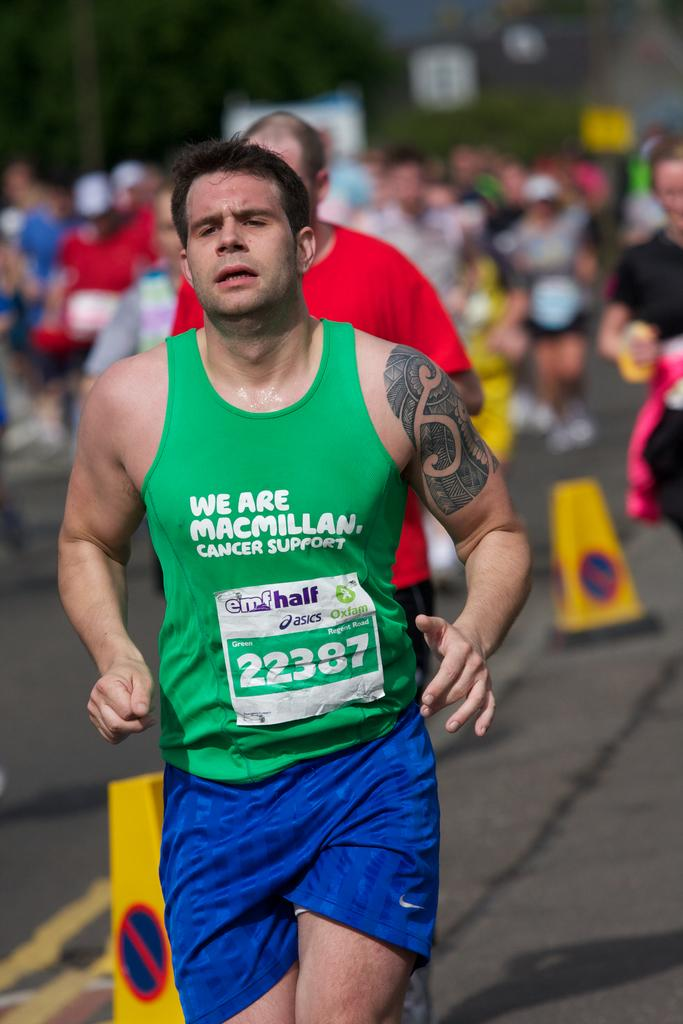What is happening in the image involving a group of people? Some people are running on the road in the image. What can be seen on the road besides the people? There are road divider blocks visible in the image. How would you describe the background of the image? The background of the image appears blurry. Where is the crate located in the image? There is no crate present in the image. What type of zebra can be seen in the background of the image? There is no zebra present in the image; the background appears blurry. 